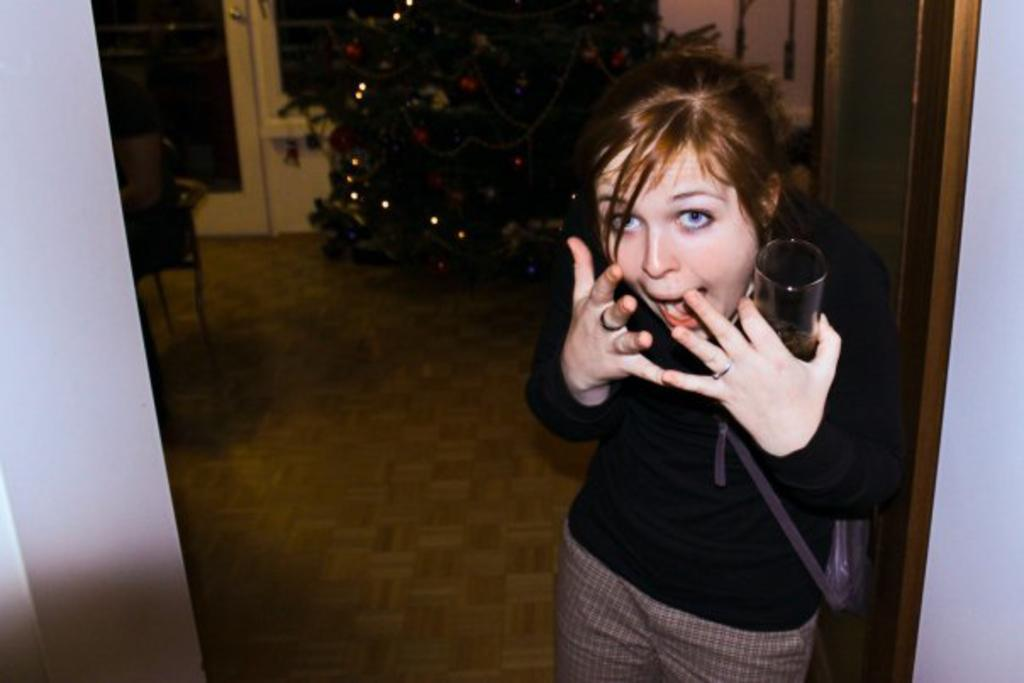What is the person in the image doing? The person is standing in the image and holding a glass. What can be seen in the background of the image? There is a plant, lights, and glass doors in the background of the image. Can you see a parrot flying over the ocean in the image? There is no ocean or parrot present in the image. 